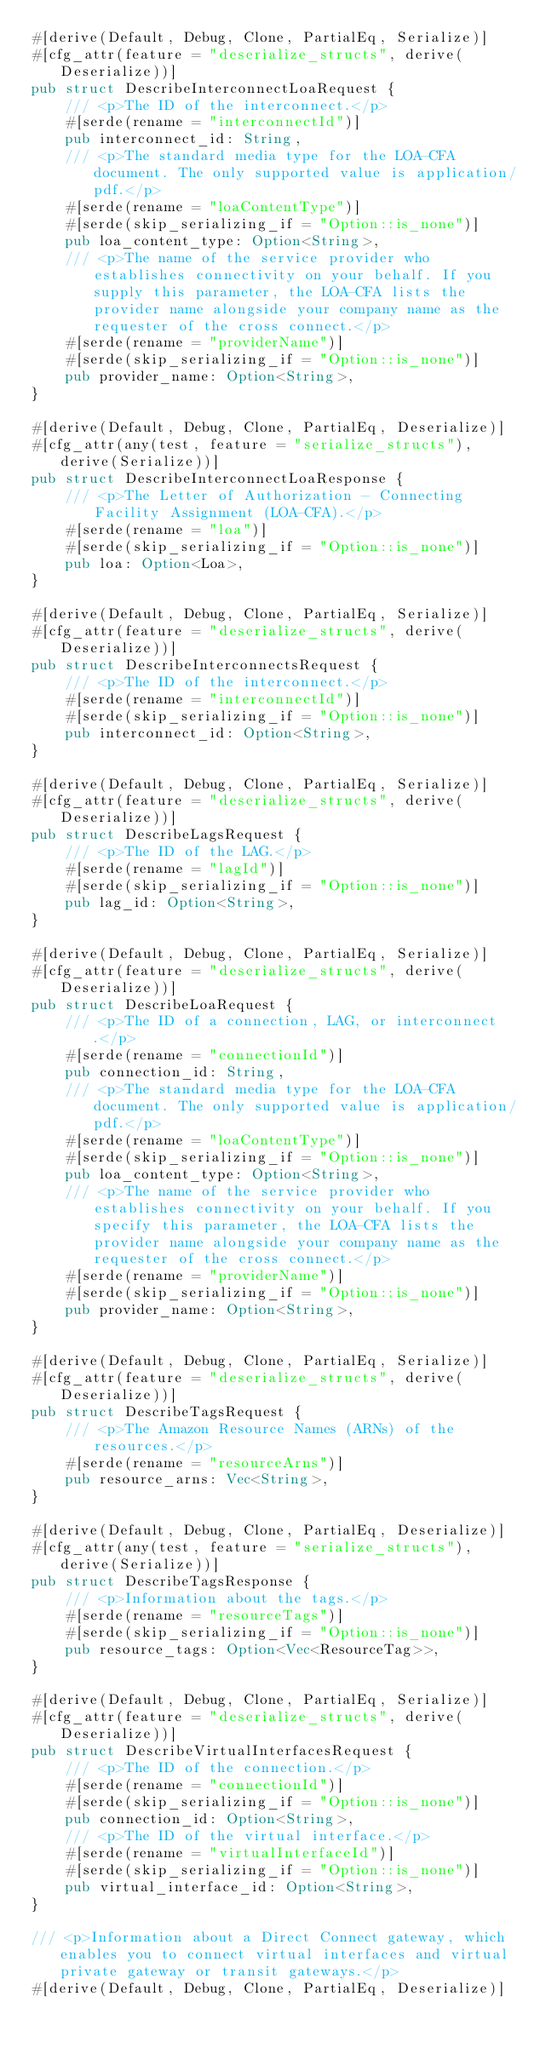<code> <loc_0><loc_0><loc_500><loc_500><_Rust_>#[derive(Default, Debug, Clone, PartialEq, Serialize)]
#[cfg_attr(feature = "deserialize_structs", derive(Deserialize))]
pub struct DescribeInterconnectLoaRequest {
    /// <p>The ID of the interconnect.</p>
    #[serde(rename = "interconnectId")]
    pub interconnect_id: String,
    /// <p>The standard media type for the LOA-CFA document. The only supported value is application/pdf.</p>
    #[serde(rename = "loaContentType")]
    #[serde(skip_serializing_if = "Option::is_none")]
    pub loa_content_type: Option<String>,
    /// <p>The name of the service provider who establishes connectivity on your behalf. If you supply this parameter, the LOA-CFA lists the provider name alongside your company name as the requester of the cross connect.</p>
    #[serde(rename = "providerName")]
    #[serde(skip_serializing_if = "Option::is_none")]
    pub provider_name: Option<String>,
}

#[derive(Default, Debug, Clone, PartialEq, Deserialize)]
#[cfg_attr(any(test, feature = "serialize_structs"), derive(Serialize))]
pub struct DescribeInterconnectLoaResponse {
    /// <p>The Letter of Authorization - Connecting Facility Assignment (LOA-CFA).</p>
    #[serde(rename = "loa")]
    #[serde(skip_serializing_if = "Option::is_none")]
    pub loa: Option<Loa>,
}

#[derive(Default, Debug, Clone, PartialEq, Serialize)]
#[cfg_attr(feature = "deserialize_structs", derive(Deserialize))]
pub struct DescribeInterconnectsRequest {
    /// <p>The ID of the interconnect.</p>
    #[serde(rename = "interconnectId")]
    #[serde(skip_serializing_if = "Option::is_none")]
    pub interconnect_id: Option<String>,
}

#[derive(Default, Debug, Clone, PartialEq, Serialize)]
#[cfg_attr(feature = "deserialize_structs", derive(Deserialize))]
pub struct DescribeLagsRequest {
    /// <p>The ID of the LAG.</p>
    #[serde(rename = "lagId")]
    #[serde(skip_serializing_if = "Option::is_none")]
    pub lag_id: Option<String>,
}

#[derive(Default, Debug, Clone, PartialEq, Serialize)]
#[cfg_attr(feature = "deserialize_structs", derive(Deserialize))]
pub struct DescribeLoaRequest {
    /// <p>The ID of a connection, LAG, or interconnect.</p>
    #[serde(rename = "connectionId")]
    pub connection_id: String,
    /// <p>The standard media type for the LOA-CFA document. The only supported value is application/pdf.</p>
    #[serde(rename = "loaContentType")]
    #[serde(skip_serializing_if = "Option::is_none")]
    pub loa_content_type: Option<String>,
    /// <p>The name of the service provider who establishes connectivity on your behalf. If you specify this parameter, the LOA-CFA lists the provider name alongside your company name as the requester of the cross connect.</p>
    #[serde(rename = "providerName")]
    #[serde(skip_serializing_if = "Option::is_none")]
    pub provider_name: Option<String>,
}

#[derive(Default, Debug, Clone, PartialEq, Serialize)]
#[cfg_attr(feature = "deserialize_structs", derive(Deserialize))]
pub struct DescribeTagsRequest {
    /// <p>The Amazon Resource Names (ARNs) of the resources.</p>
    #[serde(rename = "resourceArns")]
    pub resource_arns: Vec<String>,
}

#[derive(Default, Debug, Clone, PartialEq, Deserialize)]
#[cfg_attr(any(test, feature = "serialize_structs"), derive(Serialize))]
pub struct DescribeTagsResponse {
    /// <p>Information about the tags.</p>
    #[serde(rename = "resourceTags")]
    #[serde(skip_serializing_if = "Option::is_none")]
    pub resource_tags: Option<Vec<ResourceTag>>,
}

#[derive(Default, Debug, Clone, PartialEq, Serialize)]
#[cfg_attr(feature = "deserialize_structs", derive(Deserialize))]
pub struct DescribeVirtualInterfacesRequest {
    /// <p>The ID of the connection.</p>
    #[serde(rename = "connectionId")]
    #[serde(skip_serializing_if = "Option::is_none")]
    pub connection_id: Option<String>,
    /// <p>The ID of the virtual interface.</p>
    #[serde(rename = "virtualInterfaceId")]
    #[serde(skip_serializing_if = "Option::is_none")]
    pub virtual_interface_id: Option<String>,
}

/// <p>Information about a Direct Connect gateway, which enables you to connect virtual interfaces and virtual private gateway or transit gateways.</p>
#[derive(Default, Debug, Clone, PartialEq, Deserialize)]</code> 